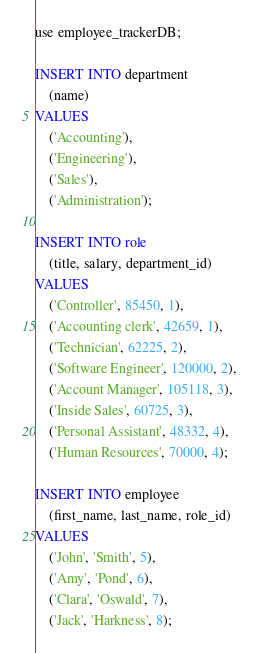Convert code to text. <code><loc_0><loc_0><loc_500><loc_500><_SQL_>use employee_trackerDB;

INSERT INTO department
    (name)
VALUES
    ('Accounting'),
    ('Engineering'),
    ('Sales'),
    ('Administration');

INSERT INTO role
    (title, salary, department_id)
VALUES
    ('Controller', 85450, 1),
    ('Accounting clerk', 42659, 1),
    ('Technician', 62225, 2),
    ('Software Engineer', 120000, 2),
    ('Account Manager', 105118, 3),
    ('Inside Sales', 60725, 3),
    ('Personal Assistant', 48332, 4),
    ('Human Resources', 70000, 4);

INSERT INTO employee
    (first_name, last_name, role_id)
VALUES
    ('John', 'Smith', 5),
    ('Amy', 'Pond', 6),
    ('Clara', 'Oswald', 7),
    ('Jack', 'Harkness', 8);</code> 